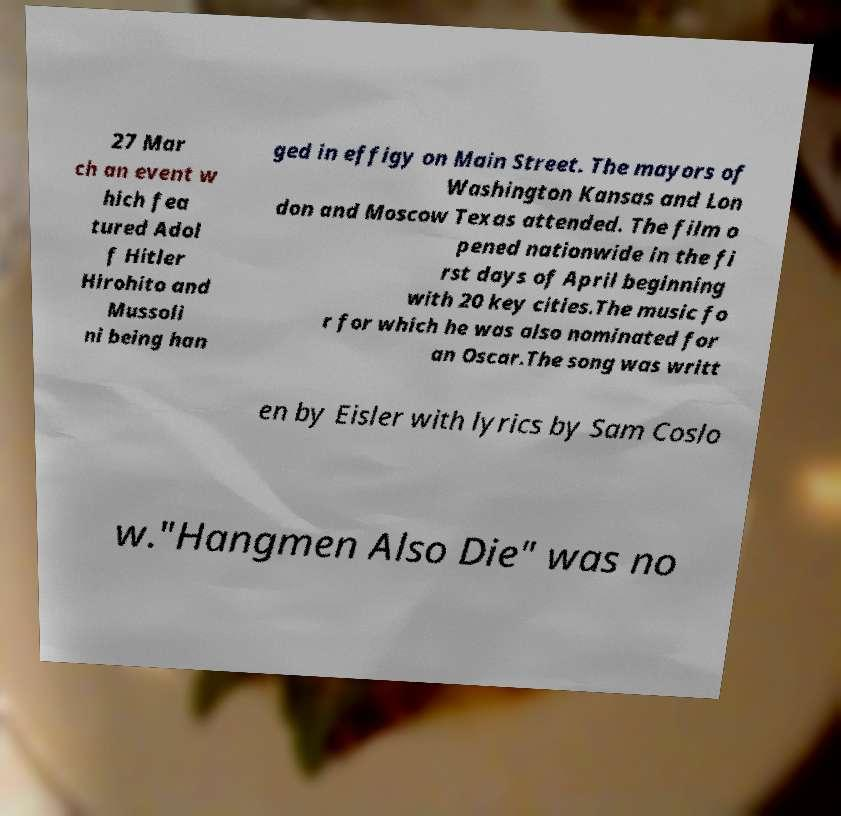For documentation purposes, I need the text within this image transcribed. Could you provide that? 27 Mar ch an event w hich fea tured Adol f Hitler Hirohito and Mussoli ni being han ged in effigy on Main Street. The mayors of Washington Kansas and Lon don and Moscow Texas attended. The film o pened nationwide in the fi rst days of April beginning with 20 key cities.The music fo r for which he was also nominated for an Oscar.The song was writt en by Eisler with lyrics by Sam Coslo w."Hangmen Also Die" was no 